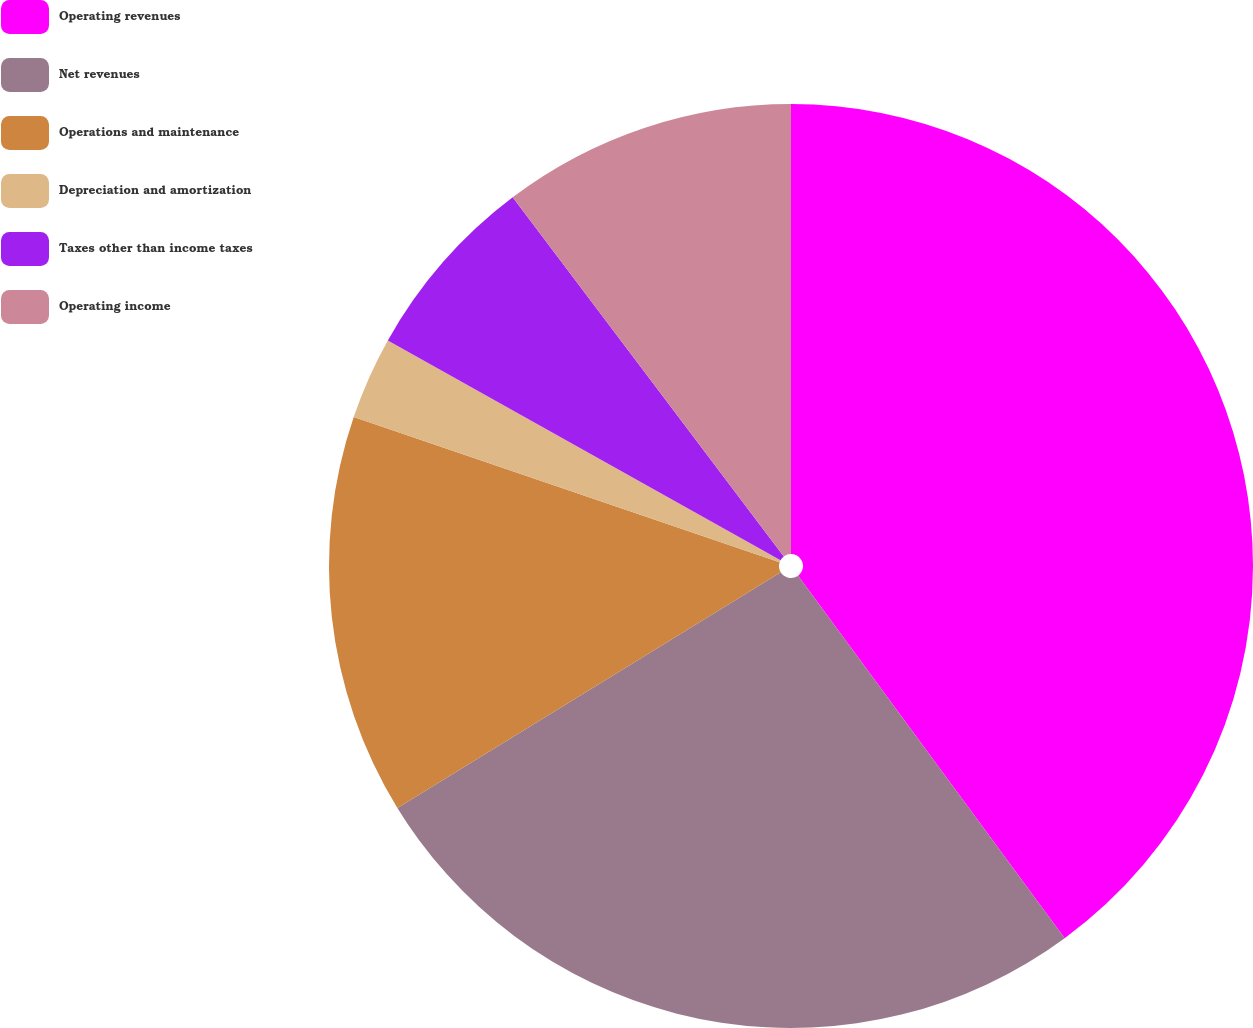Convert chart to OTSL. <chart><loc_0><loc_0><loc_500><loc_500><pie_chart><fcel>Operating revenues<fcel>Net revenues<fcel>Operations and maintenance<fcel>Depreciation and amortization<fcel>Taxes other than income taxes<fcel>Operating income<nl><fcel>39.91%<fcel>26.32%<fcel>14.0%<fcel>2.89%<fcel>6.59%<fcel>10.29%<nl></chart> 